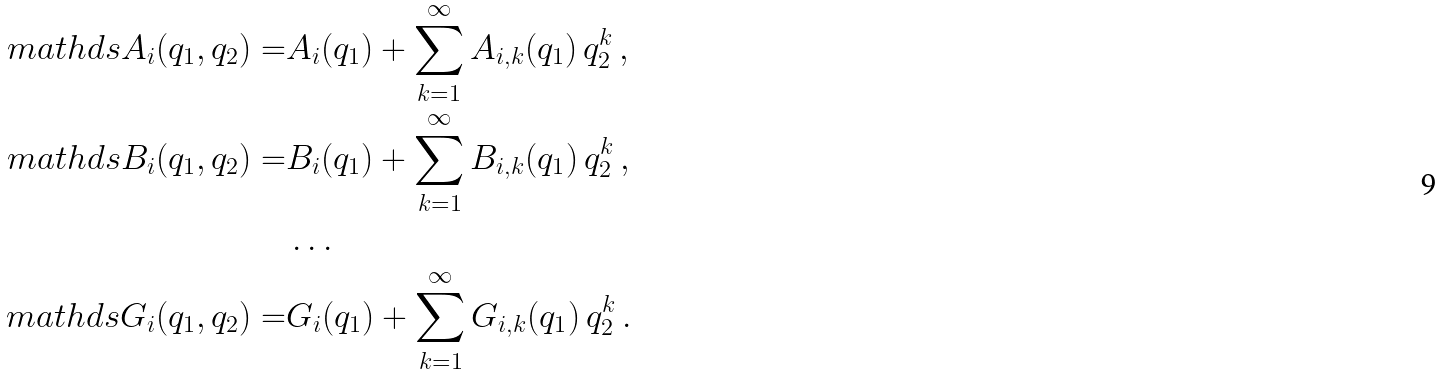Convert formula to latex. <formula><loc_0><loc_0><loc_500><loc_500>\ m a t h d s { A } _ { i } ( q _ { 1 } , q _ { 2 } ) = & A _ { i } ( q _ { 1 } ) + \sum _ { k = 1 } ^ { \infty } A _ { i , k } ( q _ { 1 } ) \, q _ { 2 } ^ { k } \, , \\ \ m a t h d s { B } _ { i } ( q _ { 1 } , q _ { 2 } ) = & B _ { i } ( q _ { 1 } ) + \sum _ { k = 1 } ^ { \infty } B _ { i , k } ( q _ { 1 } ) \, q _ { 2 } ^ { k } \, , \\ & \dots \, \\ \ m a t h d s { G } _ { i } ( q _ { 1 } , q _ { 2 } ) = & G _ { i } ( q _ { 1 } ) + \sum _ { k = 1 } ^ { \infty } G _ { i , k } ( q _ { 1 } ) \, q _ { 2 } ^ { k } \, .</formula> 